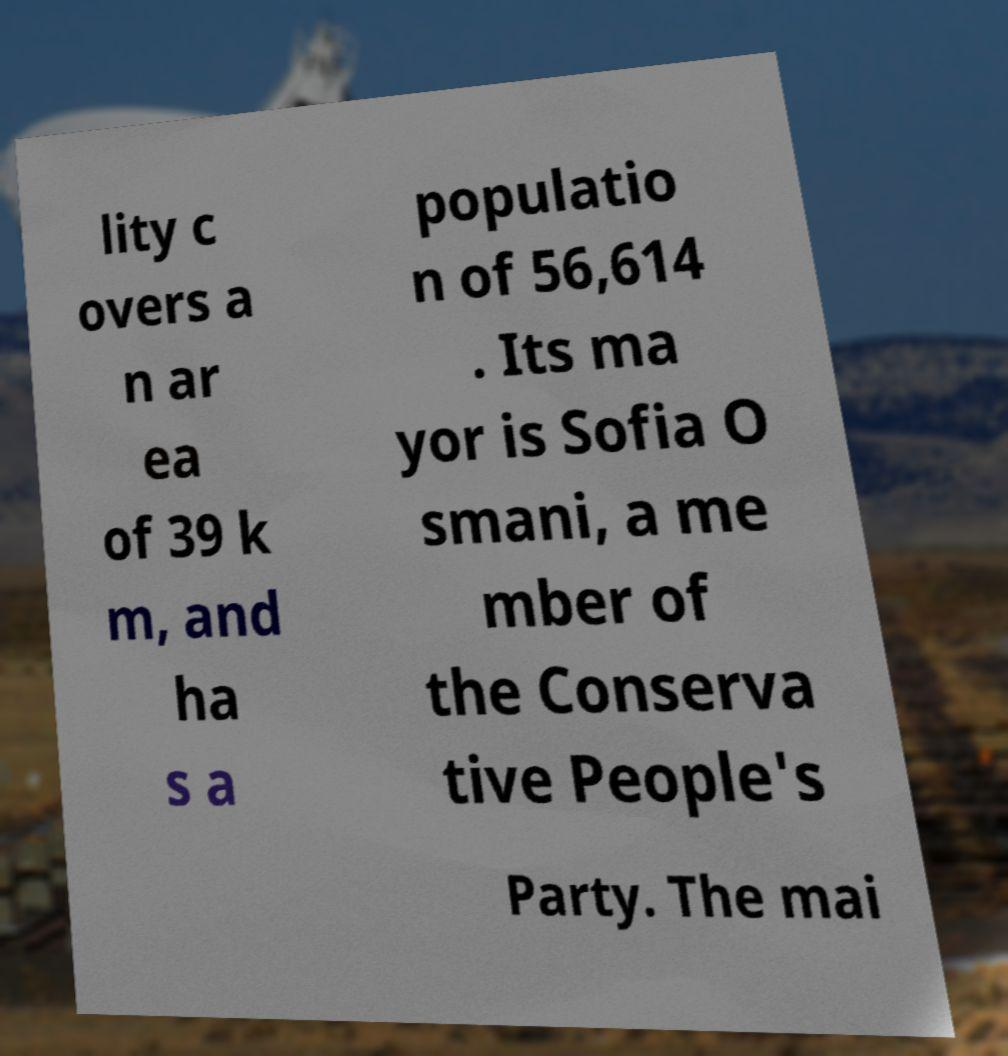I need the written content from this picture converted into text. Can you do that? lity c overs a n ar ea of 39 k m, and ha s a populatio n of 56,614 . Its ma yor is Sofia O smani, a me mber of the Conserva tive People's Party. The mai 